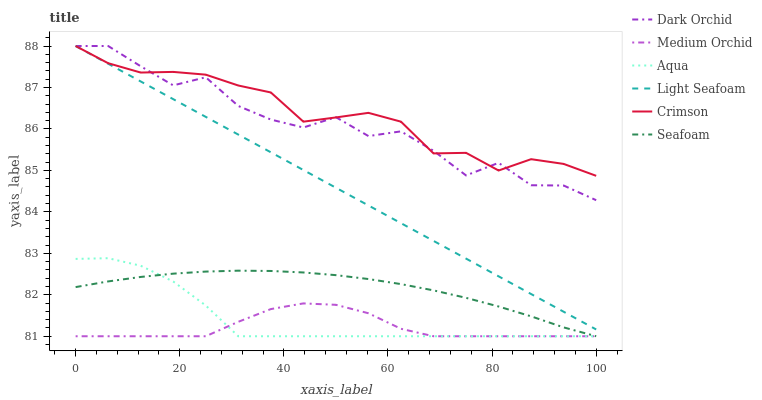Does Aqua have the minimum area under the curve?
Answer yes or no. No. Does Aqua have the maximum area under the curve?
Answer yes or no. No. Is Aqua the smoothest?
Answer yes or no. No. Is Aqua the roughest?
Answer yes or no. No. Does Dark Orchid have the lowest value?
Answer yes or no. No. Does Aqua have the highest value?
Answer yes or no. No. Is Seafoam less than Dark Orchid?
Answer yes or no. Yes. Is Dark Orchid greater than Seafoam?
Answer yes or no. Yes. Does Seafoam intersect Dark Orchid?
Answer yes or no. No. 